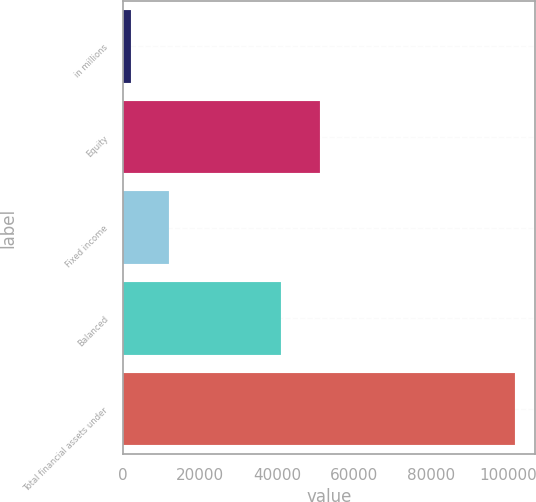Convert chart. <chart><loc_0><loc_0><loc_500><loc_500><bar_chart><fcel>in millions<fcel>Equity<fcel>Fixed income<fcel>Balanced<fcel>Total financial assets under<nl><fcel>2017<fcel>51020.6<fcel>11994.6<fcel>41043<fcel>101793<nl></chart> 